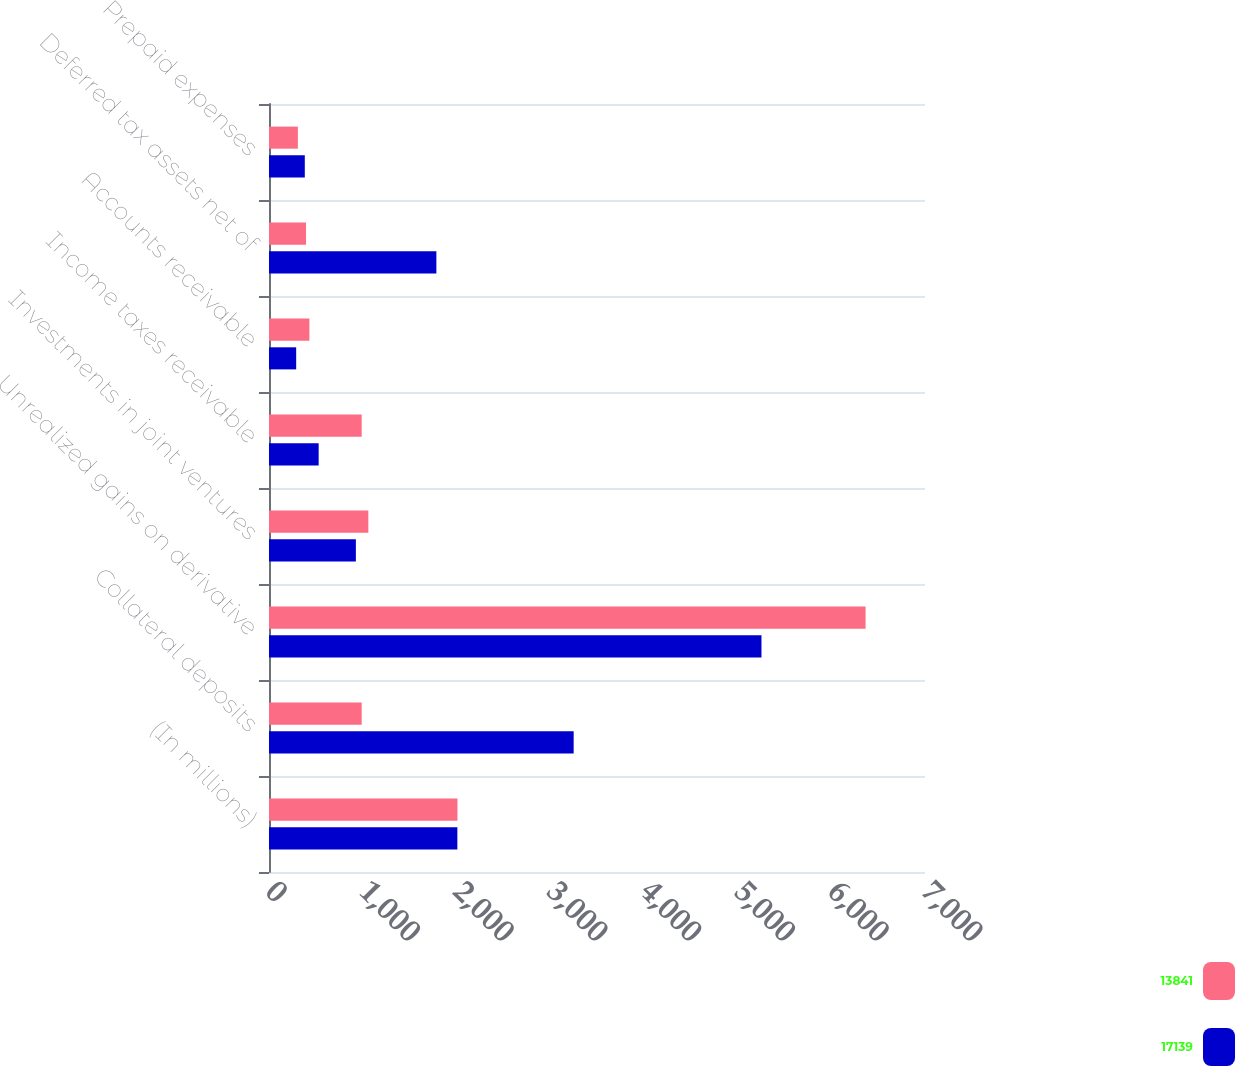Convert chart. <chart><loc_0><loc_0><loc_500><loc_500><stacked_bar_chart><ecel><fcel>(In millions)<fcel>Collateral deposits<fcel>Unrealized gains on derivative<fcel>Investments in joint ventures<fcel>Income taxes receivable<fcel>Accounts receivable<fcel>Deferred tax assets net of<fcel>Prepaid expenses<nl><fcel>13841<fcel>2011<fcel>989<fcel>6366<fcel>1060<fcel>989<fcel>431<fcel>395<fcel>308<nl><fcel>17139<fcel>2010<fcel>3251<fcel>5255<fcel>927<fcel>530<fcel>290<fcel>1786<fcel>382<nl></chart> 